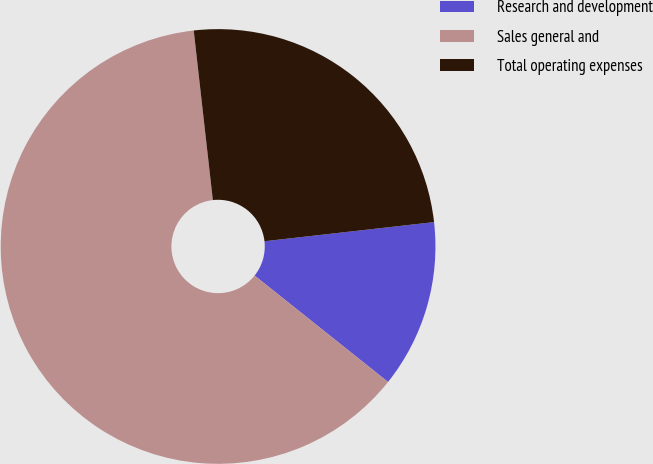<chart> <loc_0><loc_0><loc_500><loc_500><pie_chart><fcel>Research and development<fcel>Sales general and<fcel>Total operating expenses<nl><fcel>12.5%<fcel>62.5%<fcel>25.0%<nl></chart> 